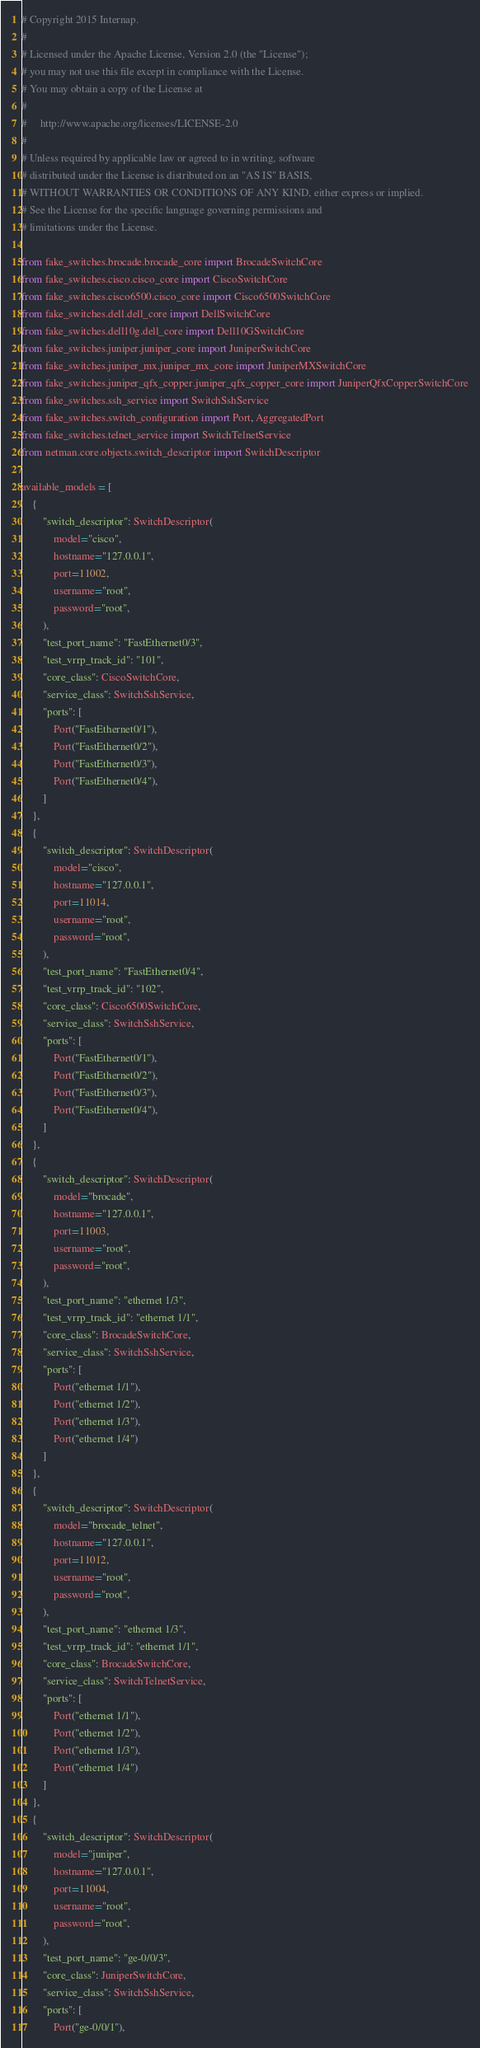<code> <loc_0><loc_0><loc_500><loc_500><_Python_># Copyright 2015 Internap.
#
# Licensed under the Apache License, Version 2.0 (the "License");
# you may not use this file except in compliance with the License.
# You may obtain a copy of the License at
#
#     http://www.apache.org/licenses/LICENSE-2.0
#
# Unless required by applicable law or agreed to in writing, software
# distributed under the License is distributed on an "AS IS" BASIS,
# WITHOUT WARRANTIES OR CONDITIONS OF ANY KIND, either express or implied.
# See the License for the specific language governing permissions and
# limitations under the License.

from fake_switches.brocade.brocade_core import BrocadeSwitchCore
from fake_switches.cisco.cisco_core import CiscoSwitchCore
from fake_switches.cisco6500.cisco_core import Cisco6500SwitchCore
from fake_switches.dell.dell_core import DellSwitchCore
from fake_switches.dell10g.dell_core import Dell10GSwitchCore
from fake_switches.juniper.juniper_core import JuniperSwitchCore
from fake_switches.juniper_mx.juniper_mx_core import JuniperMXSwitchCore
from fake_switches.juniper_qfx_copper.juniper_qfx_copper_core import JuniperQfxCopperSwitchCore
from fake_switches.ssh_service import SwitchSshService
from fake_switches.switch_configuration import Port, AggregatedPort
from fake_switches.telnet_service import SwitchTelnetService
from netman.core.objects.switch_descriptor import SwitchDescriptor

available_models = [
    {
        "switch_descriptor": SwitchDescriptor(
            model="cisco",
            hostname="127.0.0.1",
            port=11002,
            username="root",
            password="root",
        ),
        "test_port_name": "FastEthernet0/3",
        "test_vrrp_track_id": "101",
        "core_class": CiscoSwitchCore,
        "service_class": SwitchSshService,
        "ports": [
            Port("FastEthernet0/1"),
            Port("FastEthernet0/2"),
            Port("FastEthernet0/3"),
            Port("FastEthernet0/4"),
        ]
    },
    {
        "switch_descriptor": SwitchDescriptor(
            model="cisco",
            hostname="127.0.0.1",
            port=11014,
            username="root",
            password="root",
        ),
        "test_port_name": "FastEthernet0/4",
        "test_vrrp_track_id": "102",
        "core_class": Cisco6500SwitchCore,
        "service_class": SwitchSshService,
        "ports": [
            Port("FastEthernet0/1"),
            Port("FastEthernet0/2"),
            Port("FastEthernet0/3"),
            Port("FastEthernet0/4"),
        ]
    },
    {
        "switch_descriptor": SwitchDescriptor(
            model="brocade",
            hostname="127.0.0.1",
            port=11003,
            username="root",
            password="root",
        ),
        "test_port_name": "ethernet 1/3",
        "test_vrrp_track_id": "ethernet 1/1",
        "core_class": BrocadeSwitchCore,
        "service_class": SwitchSshService,
        "ports": [
            Port("ethernet 1/1"),
            Port("ethernet 1/2"),
            Port("ethernet 1/3"),
            Port("ethernet 1/4")
        ]
    },
    {
        "switch_descriptor": SwitchDescriptor(
            model="brocade_telnet",
            hostname="127.0.0.1",
            port=11012,
            username="root",
            password="root",
        ),
        "test_port_name": "ethernet 1/3",
        "test_vrrp_track_id": "ethernet 1/1",
        "core_class": BrocadeSwitchCore,
        "service_class": SwitchTelnetService,
        "ports": [
            Port("ethernet 1/1"),
            Port("ethernet 1/2"),
            Port("ethernet 1/3"),
            Port("ethernet 1/4")
        ]
    },
    {
        "switch_descriptor": SwitchDescriptor(
            model="juniper",
            hostname="127.0.0.1",
            port=11004,
            username="root",
            password="root",
        ),
        "test_port_name": "ge-0/0/3",
        "core_class": JuniperSwitchCore,
        "service_class": SwitchSshService,
        "ports": [
            Port("ge-0/0/1"),</code> 